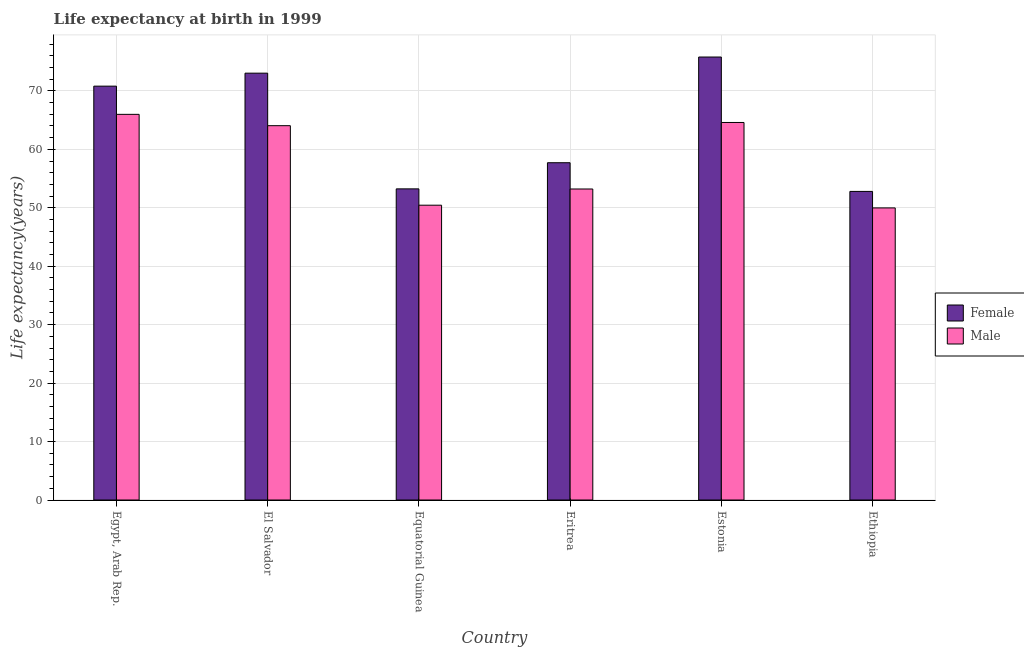How many groups of bars are there?
Offer a very short reply. 6. Are the number of bars per tick equal to the number of legend labels?
Ensure brevity in your answer.  Yes. How many bars are there on the 2nd tick from the right?
Your response must be concise. 2. What is the label of the 3rd group of bars from the left?
Offer a very short reply. Equatorial Guinea. What is the life expectancy(male) in Eritrea?
Your response must be concise. 53.22. Across all countries, what is the maximum life expectancy(male)?
Ensure brevity in your answer.  65.99. Across all countries, what is the minimum life expectancy(male)?
Make the answer very short. 49.98. In which country was the life expectancy(female) maximum?
Offer a very short reply. Estonia. In which country was the life expectancy(male) minimum?
Ensure brevity in your answer.  Ethiopia. What is the total life expectancy(male) in the graph?
Provide a succinct answer. 348.29. What is the difference between the life expectancy(male) in El Salvador and that in Equatorial Guinea?
Provide a succinct answer. 13.61. What is the difference between the life expectancy(male) in Equatorial Guinea and the life expectancy(female) in El Salvador?
Give a very brief answer. -22.59. What is the average life expectancy(female) per country?
Ensure brevity in your answer.  63.9. What is the difference between the life expectancy(female) and life expectancy(male) in Estonia?
Your answer should be very brief. 11.2. In how many countries, is the life expectancy(female) greater than 26 years?
Your answer should be very brief. 6. What is the ratio of the life expectancy(male) in Egypt, Arab Rep. to that in El Salvador?
Offer a very short reply. 1.03. Is the life expectancy(male) in Egypt, Arab Rep. less than that in Equatorial Guinea?
Keep it short and to the point. No. Is the difference between the life expectancy(female) in Equatorial Guinea and Estonia greater than the difference between the life expectancy(male) in Equatorial Guinea and Estonia?
Keep it short and to the point. No. What is the difference between the highest and the second highest life expectancy(male)?
Ensure brevity in your answer.  1.39. What is the difference between the highest and the lowest life expectancy(male)?
Provide a succinct answer. 16.01. Is the sum of the life expectancy(male) in Egypt, Arab Rep. and Eritrea greater than the maximum life expectancy(female) across all countries?
Your answer should be compact. Yes. What does the 2nd bar from the left in Equatorial Guinea represents?
Offer a terse response. Male. What does the 2nd bar from the right in El Salvador represents?
Provide a succinct answer. Female. How many bars are there?
Provide a short and direct response. 12. How many countries are there in the graph?
Ensure brevity in your answer.  6. What is the difference between two consecutive major ticks on the Y-axis?
Your response must be concise. 10. Does the graph contain grids?
Ensure brevity in your answer.  Yes. How many legend labels are there?
Your answer should be compact. 2. What is the title of the graph?
Provide a succinct answer. Life expectancy at birth in 1999. Does "All education staff compensation" appear as one of the legend labels in the graph?
Your response must be concise. No. What is the label or title of the Y-axis?
Keep it short and to the point. Life expectancy(years). What is the Life expectancy(years) of Female in Egypt, Arab Rep.?
Your answer should be compact. 70.82. What is the Life expectancy(years) in Male in Egypt, Arab Rep.?
Make the answer very short. 65.99. What is the Life expectancy(years) in Female in El Salvador?
Give a very brief answer. 73.04. What is the Life expectancy(years) of Male in El Salvador?
Give a very brief answer. 64.05. What is the Life expectancy(years) in Female in Equatorial Guinea?
Give a very brief answer. 53.24. What is the Life expectancy(years) in Male in Equatorial Guinea?
Your answer should be compact. 50.45. What is the Life expectancy(years) of Female in Eritrea?
Provide a succinct answer. 57.71. What is the Life expectancy(years) of Male in Eritrea?
Your answer should be compact. 53.22. What is the Life expectancy(years) of Female in Estonia?
Provide a succinct answer. 75.8. What is the Life expectancy(years) of Male in Estonia?
Offer a terse response. 64.6. What is the Life expectancy(years) in Female in Ethiopia?
Provide a short and direct response. 52.8. What is the Life expectancy(years) of Male in Ethiopia?
Offer a terse response. 49.98. Across all countries, what is the maximum Life expectancy(years) of Female?
Provide a short and direct response. 75.8. Across all countries, what is the maximum Life expectancy(years) in Male?
Provide a short and direct response. 65.99. Across all countries, what is the minimum Life expectancy(years) in Female?
Offer a very short reply. 52.8. Across all countries, what is the minimum Life expectancy(years) of Male?
Your response must be concise. 49.98. What is the total Life expectancy(years) of Female in the graph?
Offer a very short reply. 383.41. What is the total Life expectancy(years) of Male in the graph?
Your answer should be compact. 348.29. What is the difference between the Life expectancy(years) of Female in Egypt, Arab Rep. and that in El Salvador?
Keep it short and to the point. -2.22. What is the difference between the Life expectancy(years) of Male in Egypt, Arab Rep. and that in El Salvador?
Ensure brevity in your answer.  1.94. What is the difference between the Life expectancy(years) in Female in Egypt, Arab Rep. and that in Equatorial Guinea?
Offer a terse response. 17.58. What is the difference between the Life expectancy(years) in Male in Egypt, Arab Rep. and that in Equatorial Guinea?
Keep it short and to the point. 15.55. What is the difference between the Life expectancy(years) in Female in Egypt, Arab Rep. and that in Eritrea?
Make the answer very short. 13.1. What is the difference between the Life expectancy(years) in Male in Egypt, Arab Rep. and that in Eritrea?
Offer a very short reply. 12.77. What is the difference between the Life expectancy(years) of Female in Egypt, Arab Rep. and that in Estonia?
Your response must be concise. -4.98. What is the difference between the Life expectancy(years) of Male in Egypt, Arab Rep. and that in Estonia?
Your answer should be compact. 1.39. What is the difference between the Life expectancy(years) in Female in Egypt, Arab Rep. and that in Ethiopia?
Offer a very short reply. 18.01. What is the difference between the Life expectancy(years) of Male in Egypt, Arab Rep. and that in Ethiopia?
Provide a short and direct response. 16.01. What is the difference between the Life expectancy(years) in Female in El Salvador and that in Equatorial Guinea?
Your response must be concise. 19.8. What is the difference between the Life expectancy(years) in Male in El Salvador and that in Equatorial Guinea?
Offer a terse response. 13.61. What is the difference between the Life expectancy(years) in Female in El Salvador and that in Eritrea?
Offer a very short reply. 15.32. What is the difference between the Life expectancy(years) of Male in El Salvador and that in Eritrea?
Provide a succinct answer. 10.83. What is the difference between the Life expectancy(years) in Female in El Salvador and that in Estonia?
Your response must be concise. -2.76. What is the difference between the Life expectancy(years) of Male in El Salvador and that in Estonia?
Your response must be concise. -0.55. What is the difference between the Life expectancy(years) in Female in El Salvador and that in Ethiopia?
Offer a terse response. 20.23. What is the difference between the Life expectancy(years) of Male in El Salvador and that in Ethiopia?
Your answer should be very brief. 14.07. What is the difference between the Life expectancy(years) in Female in Equatorial Guinea and that in Eritrea?
Your response must be concise. -4.47. What is the difference between the Life expectancy(years) in Male in Equatorial Guinea and that in Eritrea?
Your response must be concise. -2.77. What is the difference between the Life expectancy(years) of Female in Equatorial Guinea and that in Estonia?
Ensure brevity in your answer.  -22.56. What is the difference between the Life expectancy(years) in Male in Equatorial Guinea and that in Estonia?
Make the answer very short. -14.15. What is the difference between the Life expectancy(years) of Female in Equatorial Guinea and that in Ethiopia?
Provide a short and direct response. 0.44. What is the difference between the Life expectancy(years) of Male in Equatorial Guinea and that in Ethiopia?
Provide a succinct answer. 0.46. What is the difference between the Life expectancy(years) of Female in Eritrea and that in Estonia?
Ensure brevity in your answer.  -18.09. What is the difference between the Life expectancy(years) in Male in Eritrea and that in Estonia?
Your answer should be very brief. -11.38. What is the difference between the Life expectancy(years) of Female in Eritrea and that in Ethiopia?
Your answer should be compact. 4.91. What is the difference between the Life expectancy(years) of Male in Eritrea and that in Ethiopia?
Your response must be concise. 3.24. What is the difference between the Life expectancy(years) in Female in Estonia and that in Ethiopia?
Your response must be concise. 23. What is the difference between the Life expectancy(years) of Male in Estonia and that in Ethiopia?
Offer a terse response. 14.62. What is the difference between the Life expectancy(years) of Female in Egypt, Arab Rep. and the Life expectancy(years) of Male in El Salvador?
Offer a very short reply. 6.76. What is the difference between the Life expectancy(years) in Female in Egypt, Arab Rep. and the Life expectancy(years) in Male in Equatorial Guinea?
Your response must be concise. 20.37. What is the difference between the Life expectancy(years) in Female in Egypt, Arab Rep. and the Life expectancy(years) in Male in Eritrea?
Provide a succinct answer. 17.6. What is the difference between the Life expectancy(years) in Female in Egypt, Arab Rep. and the Life expectancy(years) in Male in Estonia?
Provide a short and direct response. 6.22. What is the difference between the Life expectancy(years) in Female in Egypt, Arab Rep. and the Life expectancy(years) in Male in Ethiopia?
Offer a terse response. 20.84. What is the difference between the Life expectancy(years) in Female in El Salvador and the Life expectancy(years) in Male in Equatorial Guinea?
Make the answer very short. 22.59. What is the difference between the Life expectancy(years) in Female in El Salvador and the Life expectancy(years) in Male in Eritrea?
Provide a short and direct response. 19.82. What is the difference between the Life expectancy(years) in Female in El Salvador and the Life expectancy(years) in Male in Estonia?
Provide a short and direct response. 8.44. What is the difference between the Life expectancy(years) of Female in El Salvador and the Life expectancy(years) of Male in Ethiopia?
Provide a short and direct response. 23.06. What is the difference between the Life expectancy(years) in Female in Equatorial Guinea and the Life expectancy(years) in Male in Eritrea?
Your answer should be compact. 0.02. What is the difference between the Life expectancy(years) in Female in Equatorial Guinea and the Life expectancy(years) in Male in Estonia?
Give a very brief answer. -11.36. What is the difference between the Life expectancy(years) of Female in Equatorial Guinea and the Life expectancy(years) of Male in Ethiopia?
Your answer should be compact. 3.26. What is the difference between the Life expectancy(years) of Female in Eritrea and the Life expectancy(years) of Male in Estonia?
Ensure brevity in your answer.  -6.89. What is the difference between the Life expectancy(years) in Female in Eritrea and the Life expectancy(years) in Male in Ethiopia?
Give a very brief answer. 7.73. What is the difference between the Life expectancy(years) of Female in Estonia and the Life expectancy(years) of Male in Ethiopia?
Make the answer very short. 25.82. What is the average Life expectancy(years) in Female per country?
Give a very brief answer. 63.9. What is the average Life expectancy(years) in Male per country?
Your answer should be very brief. 58.05. What is the difference between the Life expectancy(years) in Female and Life expectancy(years) in Male in Egypt, Arab Rep.?
Provide a succinct answer. 4.83. What is the difference between the Life expectancy(years) of Female and Life expectancy(years) of Male in El Salvador?
Offer a very short reply. 8.99. What is the difference between the Life expectancy(years) of Female and Life expectancy(years) of Male in Equatorial Guinea?
Provide a short and direct response. 2.8. What is the difference between the Life expectancy(years) of Female and Life expectancy(years) of Male in Eritrea?
Your response must be concise. 4.5. What is the difference between the Life expectancy(years) in Female and Life expectancy(years) in Male in Ethiopia?
Offer a terse response. 2.82. What is the ratio of the Life expectancy(years) in Female in Egypt, Arab Rep. to that in El Salvador?
Give a very brief answer. 0.97. What is the ratio of the Life expectancy(years) in Male in Egypt, Arab Rep. to that in El Salvador?
Offer a terse response. 1.03. What is the ratio of the Life expectancy(years) of Female in Egypt, Arab Rep. to that in Equatorial Guinea?
Offer a terse response. 1.33. What is the ratio of the Life expectancy(years) of Male in Egypt, Arab Rep. to that in Equatorial Guinea?
Offer a very short reply. 1.31. What is the ratio of the Life expectancy(years) of Female in Egypt, Arab Rep. to that in Eritrea?
Your response must be concise. 1.23. What is the ratio of the Life expectancy(years) in Male in Egypt, Arab Rep. to that in Eritrea?
Make the answer very short. 1.24. What is the ratio of the Life expectancy(years) of Female in Egypt, Arab Rep. to that in Estonia?
Provide a short and direct response. 0.93. What is the ratio of the Life expectancy(years) of Male in Egypt, Arab Rep. to that in Estonia?
Provide a short and direct response. 1.02. What is the ratio of the Life expectancy(years) in Female in Egypt, Arab Rep. to that in Ethiopia?
Your answer should be very brief. 1.34. What is the ratio of the Life expectancy(years) in Male in Egypt, Arab Rep. to that in Ethiopia?
Provide a succinct answer. 1.32. What is the ratio of the Life expectancy(years) of Female in El Salvador to that in Equatorial Guinea?
Your answer should be very brief. 1.37. What is the ratio of the Life expectancy(years) of Male in El Salvador to that in Equatorial Guinea?
Offer a very short reply. 1.27. What is the ratio of the Life expectancy(years) of Female in El Salvador to that in Eritrea?
Provide a short and direct response. 1.27. What is the ratio of the Life expectancy(years) of Male in El Salvador to that in Eritrea?
Keep it short and to the point. 1.2. What is the ratio of the Life expectancy(years) in Female in El Salvador to that in Estonia?
Give a very brief answer. 0.96. What is the ratio of the Life expectancy(years) in Male in El Salvador to that in Estonia?
Give a very brief answer. 0.99. What is the ratio of the Life expectancy(years) in Female in El Salvador to that in Ethiopia?
Your answer should be very brief. 1.38. What is the ratio of the Life expectancy(years) in Male in El Salvador to that in Ethiopia?
Keep it short and to the point. 1.28. What is the ratio of the Life expectancy(years) of Female in Equatorial Guinea to that in Eritrea?
Your response must be concise. 0.92. What is the ratio of the Life expectancy(years) in Male in Equatorial Guinea to that in Eritrea?
Your response must be concise. 0.95. What is the ratio of the Life expectancy(years) of Female in Equatorial Guinea to that in Estonia?
Provide a short and direct response. 0.7. What is the ratio of the Life expectancy(years) of Male in Equatorial Guinea to that in Estonia?
Keep it short and to the point. 0.78. What is the ratio of the Life expectancy(years) in Female in Equatorial Guinea to that in Ethiopia?
Provide a succinct answer. 1.01. What is the ratio of the Life expectancy(years) of Male in Equatorial Guinea to that in Ethiopia?
Give a very brief answer. 1.01. What is the ratio of the Life expectancy(years) of Female in Eritrea to that in Estonia?
Provide a short and direct response. 0.76. What is the ratio of the Life expectancy(years) in Male in Eritrea to that in Estonia?
Offer a terse response. 0.82. What is the ratio of the Life expectancy(years) of Female in Eritrea to that in Ethiopia?
Provide a succinct answer. 1.09. What is the ratio of the Life expectancy(years) in Male in Eritrea to that in Ethiopia?
Ensure brevity in your answer.  1.06. What is the ratio of the Life expectancy(years) in Female in Estonia to that in Ethiopia?
Give a very brief answer. 1.44. What is the ratio of the Life expectancy(years) in Male in Estonia to that in Ethiopia?
Offer a terse response. 1.29. What is the difference between the highest and the second highest Life expectancy(years) of Female?
Offer a terse response. 2.76. What is the difference between the highest and the second highest Life expectancy(years) of Male?
Provide a succinct answer. 1.39. What is the difference between the highest and the lowest Life expectancy(years) of Female?
Provide a short and direct response. 23. What is the difference between the highest and the lowest Life expectancy(years) in Male?
Give a very brief answer. 16.01. 